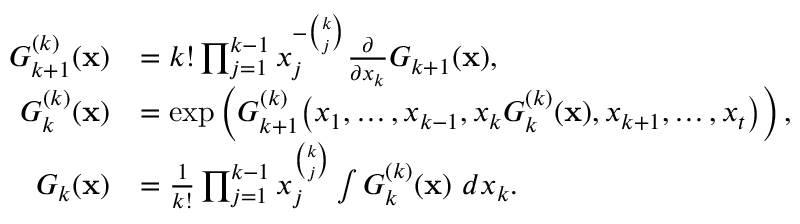Convert formula to latex. <formula><loc_0><loc_0><loc_500><loc_500>\begin{array} { r l } { G _ { k + 1 } ^ { ( k ) } ( x ) } & { = k ! \prod _ { j = 1 } ^ { k - 1 } x _ { j } ^ { - \binom { k } { j } } \frac { \partial } { \partial x _ { k } } G _ { k + 1 } ( x ) , } \\ { G _ { k } ^ { ( k ) } ( x ) } & { = \exp \left ( G _ { k + 1 } ^ { ( k ) } \left ( x _ { 1 } , \dots , x _ { k - 1 } , x _ { k } G _ { k } ^ { ( k ) } ( x ) , x _ { k + 1 } , \dots , x _ { t } \right ) \right ) , } \\ { G _ { k } ( x ) } & { = \frac { 1 } { k ! } \prod _ { j = 1 } ^ { k - 1 } x _ { j } ^ { \binom { k } { j } } \int G _ { k } ^ { ( k ) } ( x ) \, d x _ { k } . } \end{array}</formula> 